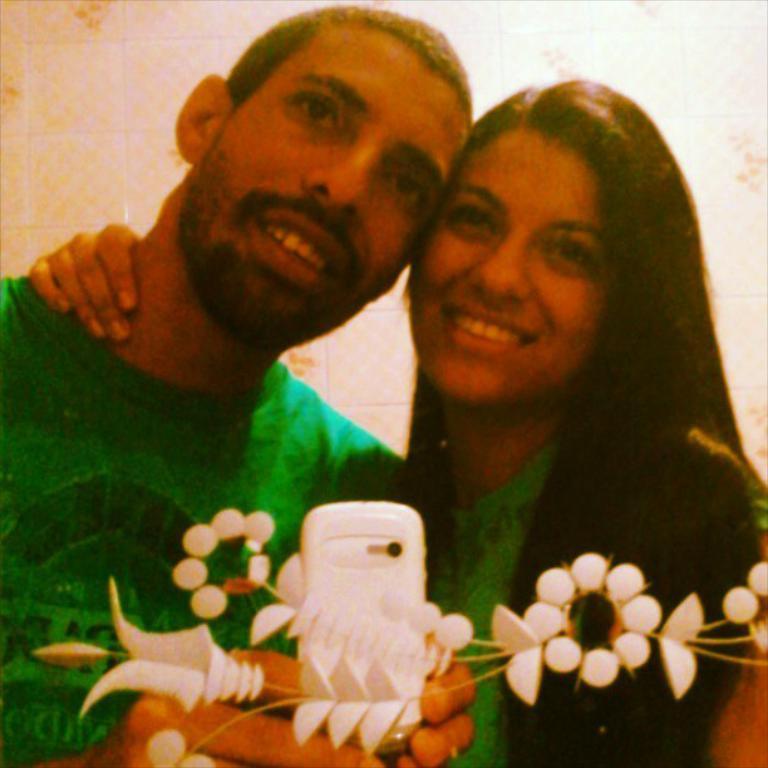Can you describe this image briefly? In the image there is a man in green t-shirt and a woman smiling and standing in front of mirror taking picture in cell phone. 